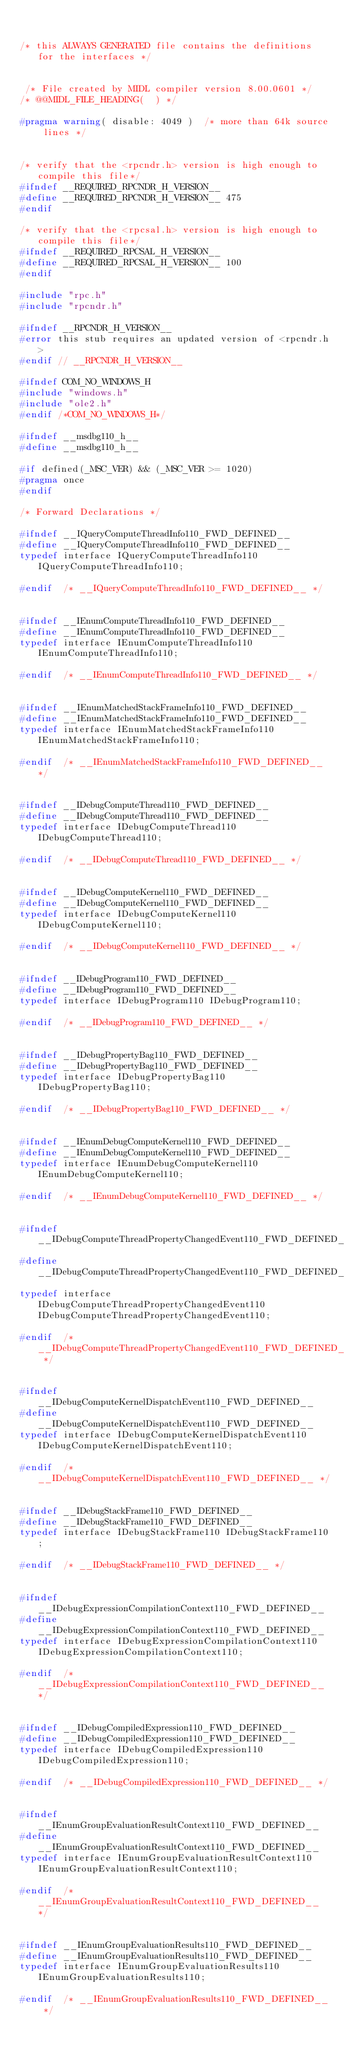<code> <loc_0><loc_0><loc_500><loc_500><_C_>

/* this ALWAYS GENERATED file contains the definitions for the interfaces */


 /* File created by MIDL compiler version 8.00.0601 */
/* @@MIDL_FILE_HEADING(  ) */

#pragma warning( disable: 4049 )  /* more than 64k source lines */


/* verify that the <rpcndr.h> version is high enough to compile this file*/
#ifndef __REQUIRED_RPCNDR_H_VERSION__
#define __REQUIRED_RPCNDR_H_VERSION__ 475
#endif

/* verify that the <rpcsal.h> version is high enough to compile this file*/
#ifndef __REQUIRED_RPCSAL_H_VERSION__
#define __REQUIRED_RPCSAL_H_VERSION__ 100
#endif

#include "rpc.h"
#include "rpcndr.h"

#ifndef __RPCNDR_H_VERSION__
#error this stub requires an updated version of <rpcndr.h>
#endif // __RPCNDR_H_VERSION__

#ifndef COM_NO_WINDOWS_H
#include "windows.h"
#include "ole2.h"
#endif /*COM_NO_WINDOWS_H*/

#ifndef __msdbg110_h__
#define __msdbg110_h__

#if defined(_MSC_VER) && (_MSC_VER >= 1020)
#pragma once
#endif

/* Forward Declarations */ 

#ifndef __IQueryComputeThreadInfo110_FWD_DEFINED__
#define __IQueryComputeThreadInfo110_FWD_DEFINED__
typedef interface IQueryComputeThreadInfo110 IQueryComputeThreadInfo110;

#endif 	/* __IQueryComputeThreadInfo110_FWD_DEFINED__ */


#ifndef __IEnumComputeThreadInfo110_FWD_DEFINED__
#define __IEnumComputeThreadInfo110_FWD_DEFINED__
typedef interface IEnumComputeThreadInfo110 IEnumComputeThreadInfo110;

#endif 	/* __IEnumComputeThreadInfo110_FWD_DEFINED__ */


#ifndef __IEnumMatchedStackFrameInfo110_FWD_DEFINED__
#define __IEnumMatchedStackFrameInfo110_FWD_DEFINED__
typedef interface IEnumMatchedStackFrameInfo110 IEnumMatchedStackFrameInfo110;

#endif 	/* __IEnumMatchedStackFrameInfo110_FWD_DEFINED__ */


#ifndef __IDebugComputeThread110_FWD_DEFINED__
#define __IDebugComputeThread110_FWD_DEFINED__
typedef interface IDebugComputeThread110 IDebugComputeThread110;

#endif 	/* __IDebugComputeThread110_FWD_DEFINED__ */


#ifndef __IDebugComputeKernel110_FWD_DEFINED__
#define __IDebugComputeKernel110_FWD_DEFINED__
typedef interface IDebugComputeKernel110 IDebugComputeKernel110;

#endif 	/* __IDebugComputeKernel110_FWD_DEFINED__ */


#ifndef __IDebugProgram110_FWD_DEFINED__
#define __IDebugProgram110_FWD_DEFINED__
typedef interface IDebugProgram110 IDebugProgram110;

#endif 	/* __IDebugProgram110_FWD_DEFINED__ */


#ifndef __IDebugPropertyBag110_FWD_DEFINED__
#define __IDebugPropertyBag110_FWD_DEFINED__
typedef interface IDebugPropertyBag110 IDebugPropertyBag110;

#endif 	/* __IDebugPropertyBag110_FWD_DEFINED__ */


#ifndef __IEnumDebugComputeKernel110_FWD_DEFINED__
#define __IEnumDebugComputeKernel110_FWD_DEFINED__
typedef interface IEnumDebugComputeKernel110 IEnumDebugComputeKernel110;

#endif 	/* __IEnumDebugComputeKernel110_FWD_DEFINED__ */


#ifndef __IDebugComputeThreadPropertyChangedEvent110_FWD_DEFINED__
#define __IDebugComputeThreadPropertyChangedEvent110_FWD_DEFINED__
typedef interface IDebugComputeThreadPropertyChangedEvent110 IDebugComputeThreadPropertyChangedEvent110;

#endif 	/* __IDebugComputeThreadPropertyChangedEvent110_FWD_DEFINED__ */


#ifndef __IDebugComputeKernelDispatchEvent110_FWD_DEFINED__
#define __IDebugComputeKernelDispatchEvent110_FWD_DEFINED__
typedef interface IDebugComputeKernelDispatchEvent110 IDebugComputeKernelDispatchEvent110;

#endif 	/* __IDebugComputeKernelDispatchEvent110_FWD_DEFINED__ */


#ifndef __IDebugStackFrame110_FWD_DEFINED__
#define __IDebugStackFrame110_FWD_DEFINED__
typedef interface IDebugStackFrame110 IDebugStackFrame110;

#endif 	/* __IDebugStackFrame110_FWD_DEFINED__ */


#ifndef __IDebugExpressionCompilationContext110_FWD_DEFINED__
#define __IDebugExpressionCompilationContext110_FWD_DEFINED__
typedef interface IDebugExpressionCompilationContext110 IDebugExpressionCompilationContext110;

#endif 	/* __IDebugExpressionCompilationContext110_FWD_DEFINED__ */


#ifndef __IDebugCompiledExpression110_FWD_DEFINED__
#define __IDebugCompiledExpression110_FWD_DEFINED__
typedef interface IDebugCompiledExpression110 IDebugCompiledExpression110;

#endif 	/* __IDebugCompiledExpression110_FWD_DEFINED__ */


#ifndef __IEnumGroupEvaluationResultContext110_FWD_DEFINED__
#define __IEnumGroupEvaluationResultContext110_FWD_DEFINED__
typedef interface IEnumGroupEvaluationResultContext110 IEnumGroupEvaluationResultContext110;

#endif 	/* __IEnumGroupEvaluationResultContext110_FWD_DEFINED__ */


#ifndef __IEnumGroupEvaluationResults110_FWD_DEFINED__
#define __IEnumGroupEvaluationResults110_FWD_DEFINED__
typedef interface IEnumGroupEvaluationResults110 IEnumGroupEvaluationResults110;

#endif 	/* __IEnumGroupEvaluationResults110_FWD_DEFINED__ */

</code> 